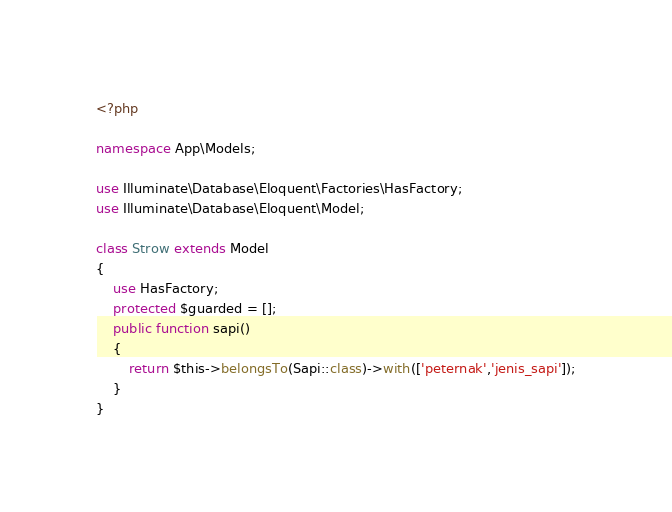Convert code to text. <code><loc_0><loc_0><loc_500><loc_500><_PHP_><?php

namespace App\Models;

use Illuminate\Database\Eloquent\Factories\HasFactory;
use Illuminate\Database\Eloquent\Model;

class Strow extends Model
{
    use HasFactory;
    protected $guarded = [];
    public function sapi()  
    {
        return $this->belongsTo(Sapi::class)->with(['peternak','jenis_sapi']);
    }
}
</code> 